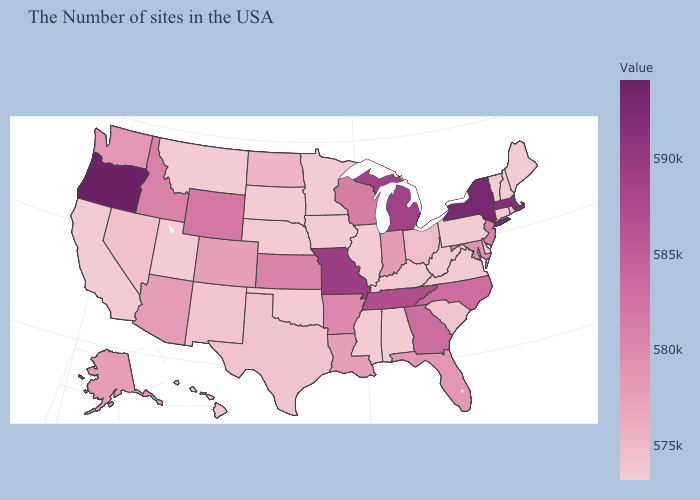Among the states that border Nebraska , which have the lowest value?
Concise answer only. Iowa, South Dakota. Among the states that border Georgia , does South Carolina have the highest value?
Write a very short answer. No. Which states hav the highest value in the Northeast?
Answer briefly. New York. 